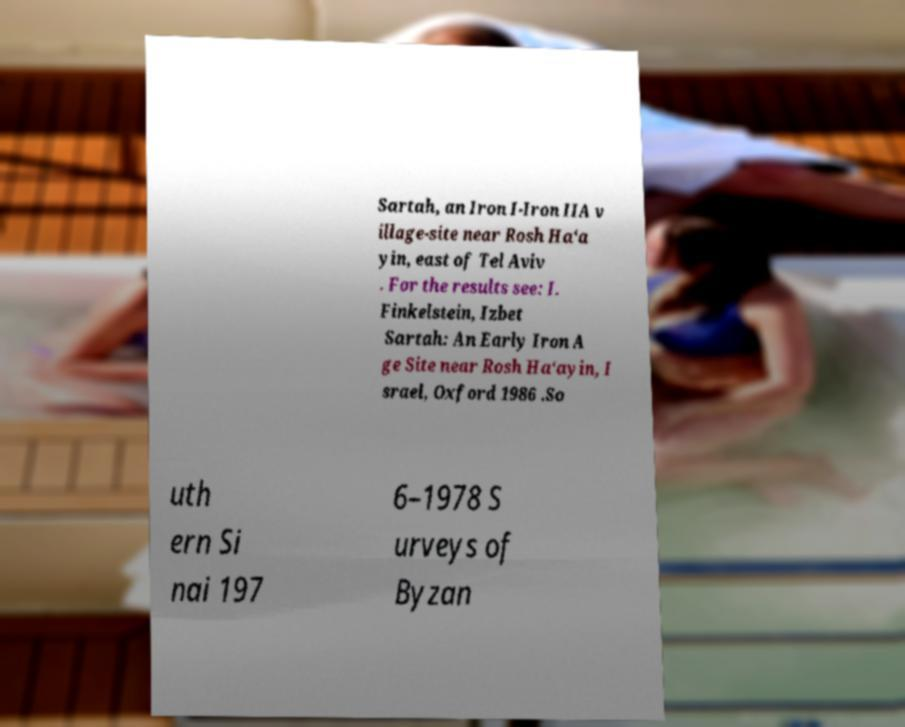I need the written content from this picture converted into text. Can you do that? Sartah, an Iron I-Iron IIA v illage-site near Rosh Ha‘a yin, east of Tel Aviv . For the results see: I. Finkelstein, Izbet Sartah: An Early Iron A ge Site near Rosh Ha‘ayin, I srael, Oxford 1986 .So uth ern Si nai 197 6–1978 S urveys of Byzan 